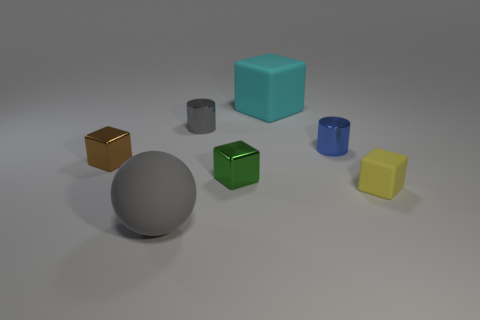Is the shape of the tiny green metal thing the same as the big object behind the small green cube?
Offer a very short reply. Yes. What is the size of the thing that is the same color as the rubber ball?
Your answer should be compact. Small. What shape is the gray thing behind the small object right of the small blue object?
Your response must be concise. Cylinder. Does the rubber thing that is to the right of the large cyan object have the same shape as the small brown object?
Give a very brief answer. Yes. What is the size of the cube that is made of the same material as the yellow thing?
Ensure brevity in your answer.  Large. What number of things are either tiny metal things on the left side of the small gray metal cylinder or things that are in front of the small blue shiny object?
Keep it short and to the point. 4. Is the number of large matte cubes that are in front of the green thing the same as the number of small cubes that are behind the tiny brown metal block?
Offer a very short reply. Yes. What is the color of the metallic cube to the left of the green cube?
Make the answer very short. Brown. Does the tiny matte thing have the same color as the large matte object in front of the small brown shiny object?
Your answer should be very brief. No. There is a small cylinder that is to the left of the tiny blue shiny cylinder; is it the same color as the ball?
Your answer should be compact. Yes. 